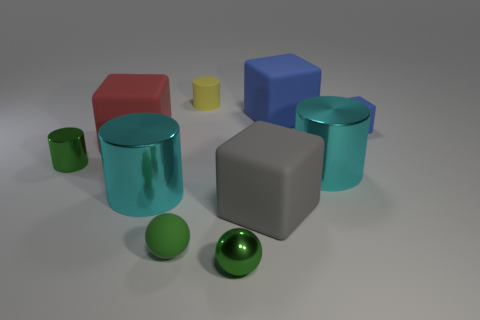There is a green cylinder that is the same size as the green matte thing; what is its material?
Provide a succinct answer. Metal. There is a small blue thing behind the gray matte object; is there a block that is to the left of it?
Provide a short and direct response. Yes. What number of other things are there of the same color as the small matte ball?
Your answer should be very brief. 2. The gray thing has what size?
Make the answer very short. Large. Are any big red metal objects visible?
Make the answer very short. No. Are there more large cyan shiny things that are to the left of the tiny rubber cube than blue rubber blocks left of the large gray cube?
Offer a terse response. Yes. What is the tiny object that is behind the green cylinder and on the left side of the small block made of?
Provide a succinct answer. Rubber. Is the shape of the big red matte thing the same as the small blue rubber object?
Make the answer very short. Yes. How many tiny green balls are on the left side of the metallic ball?
Give a very brief answer. 1. Is the size of the matte thing in front of the gray cube the same as the big blue block?
Keep it short and to the point. No. 